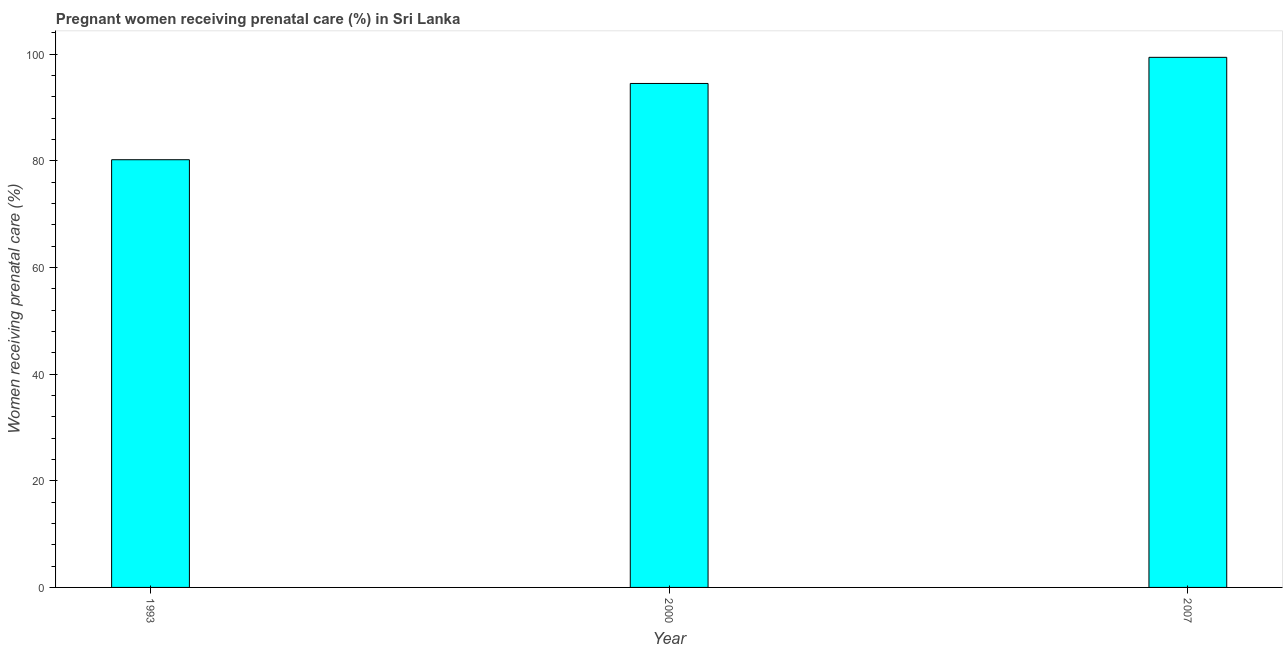Does the graph contain any zero values?
Keep it short and to the point. No. What is the title of the graph?
Offer a terse response. Pregnant women receiving prenatal care (%) in Sri Lanka. What is the label or title of the X-axis?
Your answer should be compact. Year. What is the label or title of the Y-axis?
Offer a very short reply. Women receiving prenatal care (%). What is the percentage of pregnant women receiving prenatal care in 1993?
Keep it short and to the point. 80.2. Across all years, what is the maximum percentage of pregnant women receiving prenatal care?
Offer a terse response. 99.4. Across all years, what is the minimum percentage of pregnant women receiving prenatal care?
Your response must be concise. 80.2. In which year was the percentage of pregnant women receiving prenatal care minimum?
Make the answer very short. 1993. What is the sum of the percentage of pregnant women receiving prenatal care?
Ensure brevity in your answer.  274.1. What is the average percentage of pregnant women receiving prenatal care per year?
Offer a very short reply. 91.37. What is the median percentage of pregnant women receiving prenatal care?
Provide a short and direct response. 94.5. In how many years, is the percentage of pregnant women receiving prenatal care greater than 20 %?
Your response must be concise. 3. Do a majority of the years between 2000 and 2007 (inclusive) have percentage of pregnant women receiving prenatal care greater than 16 %?
Give a very brief answer. Yes. What is the ratio of the percentage of pregnant women receiving prenatal care in 1993 to that in 2007?
Offer a very short reply. 0.81. Is the percentage of pregnant women receiving prenatal care in 1993 less than that in 2007?
Your answer should be compact. Yes. What is the difference between the highest and the second highest percentage of pregnant women receiving prenatal care?
Provide a succinct answer. 4.9. Are all the bars in the graph horizontal?
Offer a terse response. No. How many years are there in the graph?
Your answer should be compact. 3. Are the values on the major ticks of Y-axis written in scientific E-notation?
Your answer should be very brief. No. What is the Women receiving prenatal care (%) in 1993?
Your response must be concise. 80.2. What is the Women receiving prenatal care (%) in 2000?
Your answer should be very brief. 94.5. What is the Women receiving prenatal care (%) of 2007?
Ensure brevity in your answer.  99.4. What is the difference between the Women receiving prenatal care (%) in 1993 and 2000?
Offer a very short reply. -14.3. What is the difference between the Women receiving prenatal care (%) in 1993 and 2007?
Provide a succinct answer. -19.2. What is the ratio of the Women receiving prenatal care (%) in 1993 to that in 2000?
Provide a short and direct response. 0.85. What is the ratio of the Women receiving prenatal care (%) in 1993 to that in 2007?
Provide a short and direct response. 0.81. What is the ratio of the Women receiving prenatal care (%) in 2000 to that in 2007?
Make the answer very short. 0.95. 